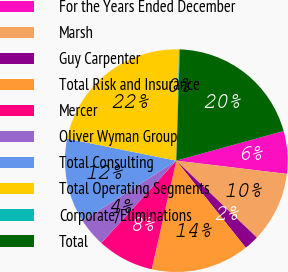Convert chart. <chart><loc_0><loc_0><loc_500><loc_500><pie_chart><fcel>For the Years Ended December<fcel>Marsh<fcel>Guy Carpenter<fcel>Total Risk and Insurance<fcel>Mercer<fcel>Oliver Wyman Group<fcel>Total Consulting<fcel>Total Operating Segments<fcel>Corporate/Eliminations<fcel>Total<nl><fcel>6.19%<fcel>10.23%<fcel>2.15%<fcel>14.27%<fcel>8.21%<fcel>4.17%<fcel>12.25%<fcel>22.22%<fcel>0.13%<fcel>20.2%<nl></chart> 